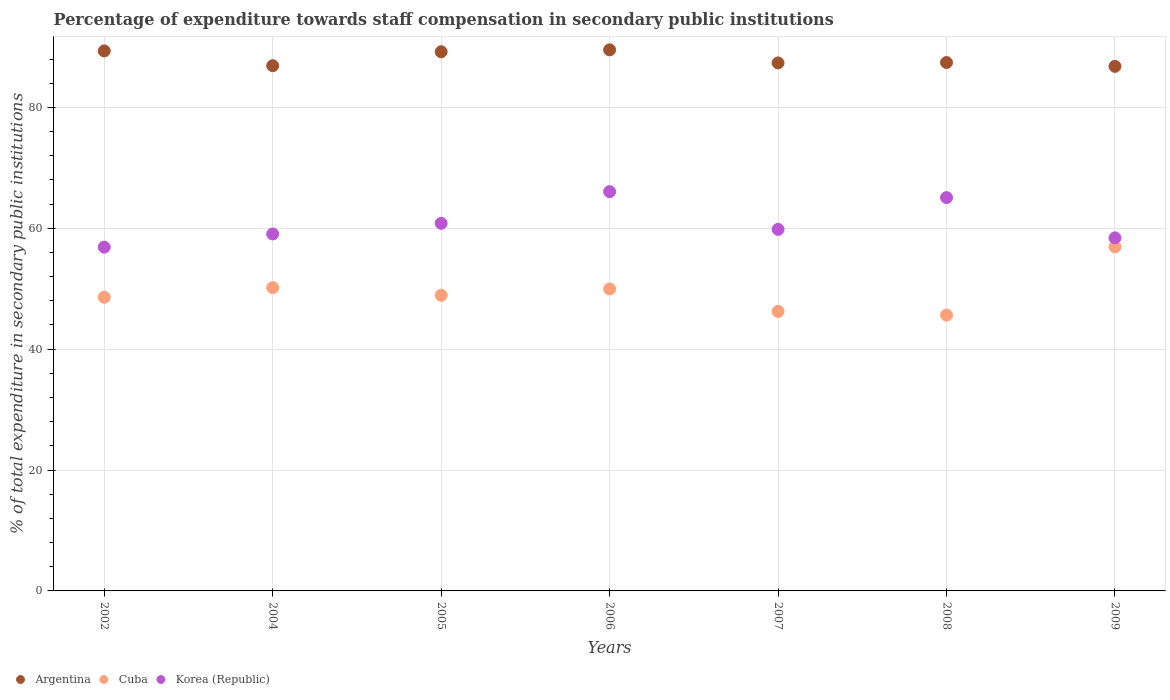How many different coloured dotlines are there?
Give a very brief answer. 3. Is the number of dotlines equal to the number of legend labels?
Offer a terse response. Yes. What is the percentage of expenditure towards staff compensation in Korea (Republic) in 2002?
Keep it short and to the point. 56.87. Across all years, what is the maximum percentage of expenditure towards staff compensation in Cuba?
Your answer should be very brief. 56.92. Across all years, what is the minimum percentage of expenditure towards staff compensation in Korea (Republic)?
Offer a terse response. 56.87. In which year was the percentage of expenditure towards staff compensation in Argentina minimum?
Offer a very short reply. 2009. What is the total percentage of expenditure towards staff compensation in Argentina in the graph?
Your answer should be compact. 616.55. What is the difference between the percentage of expenditure towards staff compensation in Cuba in 2004 and that in 2008?
Make the answer very short. 4.55. What is the difference between the percentage of expenditure towards staff compensation in Korea (Republic) in 2005 and the percentage of expenditure towards staff compensation in Argentina in 2008?
Your answer should be very brief. -26.61. What is the average percentage of expenditure towards staff compensation in Cuba per year?
Provide a short and direct response. 49.49. In the year 2005, what is the difference between the percentage of expenditure towards staff compensation in Korea (Republic) and percentage of expenditure towards staff compensation in Cuba?
Your answer should be compact. 11.9. What is the ratio of the percentage of expenditure towards staff compensation in Argentina in 2005 to that in 2006?
Provide a succinct answer. 1. Is the difference between the percentage of expenditure towards staff compensation in Korea (Republic) in 2007 and 2009 greater than the difference between the percentage of expenditure towards staff compensation in Cuba in 2007 and 2009?
Provide a short and direct response. Yes. What is the difference between the highest and the second highest percentage of expenditure towards staff compensation in Argentina?
Your answer should be compact. 0.18. What is the difference between the highest and the lowest percentage of expenditure towards staff compensation in Korea (Republic)?
Make the answer very short. 9.19. In how many years, is the percentage of expenditure towards staff compensation in Argentina greater than the average percentage of expenditure towards staff compensation in Argentina taken over all years?
Offer a terse response. 3. Does the percentage of expenditure towards staff compensation in Argentina monotonically increase over the years?
Your answer should be very brief. No. Is the percentage of expenditure towards staff compensation in Cuba strictly greater than the percentage of expenditure towards staff compensation in Argentina over the years?
Your answer should be very brief. No. How many dotlines are there?
Provide a short and direct response. 3. What is the difference between two consecutive major ticks on the Y-axis?
Keep it short and to the point. 20. Are the values on the major ticks of Y-axis written in scientific E-notation?
Your answer should be very brief. No. Does the graph contain any zero values?
Keep it short and to the point. No. How many legend labels are there?
Offer a terse response. 3. How are the legend labels stacked?
Offer a terse response. Horizontal. What is the title of the graph?
Make the answer very short. Percentage of expenditure towards staff compensation in secondary public institutions. What is the label or title of the X-axis?
Ensure brevity in your answer.  Years. What is the label or title of the Y-axis?
Your answer should be very brief. % of total expenditure in secondary public institutions. What is the % of total expenditure in secondary public institutions in Argentina in 2002?
Your answer should be very brief. 89.35. What is the % of total expenditure in secondary public institutions of Cuba in 2002?
Make the answer very short. 48.59. What is the % of total expenditure in secondary public institutions in Korea (Republic) in 2002?
Provide a short and direct response. 56.87. What is the % of total expenditure in secondary public institutions of Argentina in 2004?
Give a very brief answer. 86.9. What is the % of total expenditure in secondary public institutions of Cuba in 2004?
Keep it short and to the point. 50.18. What is the % of total expenditure in secondary public institutions of Korea (Republic) in 2004?
Keep it short and to the point. 59.06. What is the % of total expenditure in secondary public institutions in Argentina in 2005?
Your answer should be very brief. 89.2. What is the % of total expenditure in secondary public institutions of Cuba in 2005?
Keep it short and to the point. 48.92. What is the % of total expenditure in secondary public institutions in Korea (Republic) in 2005?
Offer a terse response. 60.82. What is the % of total expenditure in secondary public institutions of Argentina in 2006?
Ensure brevity in your answer.  89.52. What is the % of total expenditure in secondary public institutions of Cuba in 2006?
Ensure brevity in your answer.  49.97. What is the % of total expenditure in secondary public institutions of Korea (Republic) in 2006?
Make the answer very short. 66.06. What is the % of total expenditure in secondary public institutions in Argentina in 2007?
Give a very brief answer. 87.36. What is the % of total expenditure in secondary public institutions of Cuba in 2007?
Offer a terse response. 46.25. What is the % of total expenditure in secondary public institutions of Korea (Republic) in 2007?
Provide a succinct answer. 59.82. What is the % of total expenditure in secondary public institutions of Argentina in 2008?
Keep it short and to the point. 87.43. What is the % of total expenditure in secondary public institutions of Cuba in 2008?
Offer a terse response. 45.63. What is the % of total expenditure in secondary public institutions of Korea (Republic) in 2008?
Your response must be concise. 65.08. What is the % of total expenditure in secondary public institutions of Argentina in 2009?
Make the answer very short. 86.79. What is the % of total expenditure in secondary public institutions in Cuba in 2009?
Provide a succinct answer. 56.92. What is the % of total expenditure in secondary public institutions in Korea (Republic) in 2009?
Offer a terse response. 58.42. Across all years, what is the maximum % of total expenditure in secondary public institutions of Argentina?
Offer a very short reply. 89.52. Across all years, what is the maximum % of total expenditure in secondary public institutions of Cuba?
Offer a very short reply. 56.92. Across all years, what is the maximum % of total expenditure in secondary public institutions of Korea (Republic)?
Offer a very short reply. 66.06. Across all years, what is the minimum % of total expenditure in secondary public institutions in Argentina?
Your answer should be compact. 86.79. Across all years, what is the minimum % of total expenditure in secondary public institutions of Cuba?
Offer a terse response. 45.63. Across all years, what is the minimum % of total expenditure in secondary public institutions of Korea (Republic)?
Keep it short and to the point. 56.87. What is the total % of total expenditure in secondary public institutions of Argentina in the graph?
Your answer should be very brief. 616.55. What is the total % of total expenditure in secondary public institutions in Cuba in the graph?
Give a very brief answer. 346.45. What is the total % of total expenditure in secondary public institutions in Korea (Republic) in the graph?
Offer a very short reply. 426.13. What is the difference between the % of total expenditure in secondary public institutions of Argentina in 2002 and that in 2004?
Keep it short and to the point. 2.45. What is the difference between the % of total expenditure in secondary public institutions of Cuba in 2002 and that in 2004?
Your response must be concise. -1.59. What is the difference between the % of total expenditure in secondary public institutions in Korea (Republic) in 2002 and that in 2004?
Provide a succinct answer. -2.19. What is the difference between the % of total expenditure in secondary public institutions of Argentina in 2002 and that in 2005?
Give a very brief answer. 0.14. What is the difference between the % of total expenditure in secondary public institutions in Cuba in 2002 and that in 2005?
Offer a terse response. -0.33. What is the difference between the % of total expenditure in secondary public institutions in Korea (Republic) in 2002 and that in 2005?
Offer a very short reply. -3.94. What is the difference between the % of total expenditure in secondary public institutions in Argentina in 2002 and that in 2006?
Make the answer very short. -0.18. What is the difference between the % of total expenditure in secondary public institutions of Cuba in 2002 and that in 2006?
Ensure brevity in your answer.  -1.38. What is the difference between the % of total expenditure in secondary public institutions in Korea (Republic) in 2002 and that in 2006?
Your response must be concise. -9.19. What is the difference between the % of total expenditure in secondary public institutions of Argentina in 2002 and that in 2007?
Offer a very short reply. 1.99. What is the difference between the % of total expenditure in secondary public institutions in Cuba in 2002 and that in 2007?
Ensure brevity in your answer.  2.34. What is the difference between the % of total expenditure in secondary public institutions in Korea (Republic) in 2002 and that in 2007?
Offer a terse response. -2.94. What is the difference between the % of total expenditure in secondary public institutions of Argentina in 2002 and that in 2008?
Your response must be concise. 1.92. What is the difference between the % of total expenditure in secondary public institutions in Cuba in 2002 and that in 2008?
Provide a short and direct response. 2.96. What is the difference between the % of total expenditure in secondary public institutions in Korea (Republic) in 2002 and that in 2008?
Make the answer very short. -8.2. What is the difference between the % of total expenditure in secondary public institutions of Argentina in 2002 and that in 2009?
Give a very brief answer. 2.55. What is the difference between the % of total expenditure in secondary public institutions of Cuba in 2002 and that in 2009?
Keep it short and to the point. -8.34. What is the difference between the % of total expenditure in secondary public institutions of Korea (Republic) in 2002 and that in 2009?
Make the answer very short. -1.54. What is the difference between the % of total expenditure in secondary public institutions in Argentina in 2004 and that in 2005?
Provide a succinct answer. -2.3. What is the difference between the % of total expenditure in secondary public institutions in Cuba in 2004 and that in 2005?
Provide a succinct answer. 1.26. What is the difference between the % of total expenditure in secondary public institutions of Korea (Republic) in 2004 and that in 2005?
Give a very brief answer. -1.76. What is the difference between the % of total expenditure in secondary public institutions in Argentina in 2004 and that in 2006?
Provide a short and direct response. -2.62. What is the difference between the % of total expenditure in secondary public institutions of Cuba in 2004 and that in 2006?
Offer a very short reply. 0.21. What is the difference between the % of total expenditure in secondary public institutions in Korea (Republic) in 2004 and that in 2006?
Offer a very short reply. -7. What is the difference between the % of total expenditure in secondary public institutions of Argentina in 2004 and that in 2007?
Ensure brevity in your answer.  -0.46. What is the difference between the % of total expenditure in secondary public institutions in Cuba in 2004 and that in 2007?
Your answer should be compact. 3.93. What is the difference between the % of total expenditure in secondary public institutions in Korea (Republic) in 2004 and that in 2007?
Provide a succinct answer. -0.76. What is the difference between the % of total expenditure in secondary public institutions of Argentina in 2004 and that in 2008?
Your answer should be very brief. -0.53. What is the difference between the % of total expenditure in secondary public institutions of Cuba in 2004 and that in 2008?
Provide a short and direct response. 4.55. What is the difference between the % of total expenditure in secondary public institutions of Korea (Republic) in 2004 and that in 2008?
Keep it short and to the point. -6.02. What is the difference between the % of total expenditure in secondary public institutions in Argentina in 2004 and that in 2009?
Provide a short and direct response. 0.11. What is the difference between the % of total expenditure in secondary public institutions of Cuba in 2004 and that in 2009?
Make the answer very short. -6.74. What is the difference between the % of total expenditure in secondary public institutions of Korea (Republic) in 2004 and that in 2009?
Provide a succinct answer. 0.64. What is the difference between the % of total expenditure in secondary public institutions in Argentina in 2005 and that in 2006?
Provide a succinct answer. -0.32. What is the difference between the % of total expenditure in secondary public institutions of Cuba in 2005 and that in 2006?
Your response must be concise. -1.05. What is the difference between the % of total expenditure in secondary public institutions of Korea (Republic) in 2005 and that in 2006?
Offer a terse response. -5.24. What is the difference between the % of total expenditure in secondary public institutions in Argentina in 2005 and that in 2007?
Provide a succinct answer. 1.85. What is the difference between the % of total expenditure in secondary public institutions of Cuba in 2005 and that in 2007?
Ensure brevity in your answer.  2.67. What is the difference between the % of total expenditure in secondary public institutions of Argentina in 2005 and that in 2008?
Your response must be concise. 1.78. What is the difference between the % of total expenditure in secondary public institutions in Cuba in 2005 and that in 2008?
Your answer should be compact. 3.29. What is the difference between the % of total expenditure in secondary public institutions in Korea (Republic) in 2005 and that in 2008?
Your answer should be compact. -4.26. What is the difference between the % of total expenditure in secondary public institutions of Argentina in 2005 and that in 2009?
Provide a short and direct response. 2.41. What is the difference between the % of total expenditure in secondary public institutions of Cuba in 2005 and that in 2009?
Give a very brief answer. -8.01. What is the difference between the % of total expenditure in secondary public institutions in Korea (Republic) in 2005 and that in 2009?
Provide a short and direct response. 2.4. What is the difference between the % of total expenditure in secondary public institutions of Argentina in 2006 and that in 2007?
Your response must be concise. 2.16. What is the difference between the % of total expenditure in secondary public institutions of Cuba in 2006 and that in 2007?
Your answer should be very brief. 3.72. What is the difference between the % of total expenditure in secondary public institutions in Korea (Republic) in 2006 and that in 2007?
Provide a succinct answer. 6.24. What is the difference between the % of total expenditure in secondary public institutions of Argentina in 2006 and that in 2008?
Make the answer very short. 2.1. What is the difference between the % of total expenditure in secondary public institutions in Cuba in 2006 and that in 2008?
Your response must be concise. 4.33. What is the difference between the % of total expenditure in secondary public institutions of Korea (Republic) in 2006 and that in 2008?
Give a very brief answer. 0.98. What is the difference between the % of total expenditure in secondary public institutions in Argentina in 2006 and that in 2009?
Offer a terse response. 2.73. What is the difference between the % of total expenditure in secondary public institutions in Cuba in 2006 and that in 2009?
Make the answer very short. -6.96. What is the difference between the % of total expenditure in secondary public institutions in Korea (Republic) in 2006 and that in 2009?
Your answer should be very brief. 7.64. What is the difference between the % of total expenditure in secondary public institutions in Argentina in 2007 and that in 2008?
Provide a short and direct response. -0.07. What is the difference between the % of total expenditure in secondary public institutions in Cuba in 2007 and that in 2008?
Give a very brief answer. 0.62. What is the difference between the % of total expenditure in secondary public institutions in Korea (Republic) in 2007 and that in 2008?
Make the answer very short. -5.26. What is the difference between the % of total expenditure in secondary public institutions of Argentina in 2007 and that in 2009?
Your answer should be very brief. 0.57. What is the difference between the % of total expenditure in secondary public institutions of Cuba in 2007 and that in 2009?
Give a very brief answer. -10.68. What is the difference between the % of total expenditure in secondary public institutions of Korea (Republic) in 2007 and that in 2009?
Keep it short and to the point. 1.4. What is the difference between the % of total expenditure in secondary public institutions of Argentina in 2008 and that in 2009?
Keep it short and to the point. 0.64. What is the difference between the % of total expenditure in secondary public institutions in Cuba in 2008 and that in 2009?
Ensure brevity in your answer.  -11.29. What is the difference between the % of total expenditure in secondary public institutions in Korea (Republic) in 2008 and that in 2009?
Make the answer very short. 6.66. What is the difference between the % of total expenditure in secondary public institutions in Argentina in 2002 and the % of total expenditure in secondary public institutions in Cuba in 2004?
Provide a succinct answer. 39.17. What is the difference between the % of total expenditure in secondary public institutions in Argentina in 2002 and the % of total expenditure in secondary public institutions in Korea (Republic) in 2004?
Your answer should be very brief. 30.28. What is the difference between the % of total expenditure in secondary public institutions in Cuba in 2002 and the % of total expenditure in secondary public institutions in Korea (Republic) in 2004?
Keep it short and to the point. -10.47. What is the difference between the % of total expenditure in secondary public institutions in Argentina in 2002 and the % of total expenditure in secondary public institutions in Cuba in 2005?
Your answer should be compact. 40.43. What is the difference between the % of total expenditure in secondary public institutions of Argentina in 2002 and the % of total expenditure in secondary public institutions of Korea (Republic) in 2005?
Keep it short and to the point. 28.53. What is the difference between the % of total expenditure in secondary public institutions in Cuba in 2002 and the % of total expenditure in secondary public institutions in Korea (Republic) in 2005?
Give a very brief answer. -12.23. What is the difference between the % of total expenditure in secondary public institutions of Argentina in 2002 and the % of total expenditure in secondary public institutions of Cuba in 2006?
Offer a terse response. 39.38. What is the difference between the % of total expenditure in secondary public institutions of Argentina in 2002 and the % of total expenditure in secondary public institutions of Korea (Republic) in 2006?
Give a very brief answer. 23.28. What is the difference between the % of total expenditure in secondary public institutions of Cuba in 2002 and the % of total expenditure in secondary public institutions of Korea (Republic) in 2006?
Your answer should be compact. -17.47. What is the difference between the % of total expenditure in secondary public institutions of Argentina in 2002 and the % of total expenditure in secondary public institutions of Cuba in 2007?
Make the answer very short. 43.1. What is the difference between the % of total expenditure in secondary public institutions in Argentina in 2002 and the % of total expenditure in secondary public institutions in Korea (Republic) in 2007?
Your answer should be compact. 29.53. What is the difference between the % of total expenditure in secondary public institutions of Cuba in 2002 and the % of total expenditure in secondary public institutions of Korea (Republic) in 2007?
Provide a succinct answer. -11.23. What is the difference between the % of total expenditure in secondary public institutions in Argentina in 2002 and the % of total expenditure in secondary public institutions in Cuba in 2008?
Provide a short and direct response. 43.71. What is the difference between the % of total expenditure in secondary public institutions in Argentina in 2002 and the % of total expenditure in secondary public institutions in Korea (Republic) in 2008?
Give a very brief answer. 24.27. What is the difference between the % of total expenditure in secondary public institutions in Cuba in 2002 and the % of total expenditure in secondary public institutions in Korea (Republic) in 2008?
Your answer should be very brief. -16.49. What is the difference between the % of total expenditure in secondary public institutions of Argentina in 2002 and the % of total expenditure in secondary public institutions of Cuba in 2009?
Provide a succinct answer. 32.42. What is the difference between the % of total expenditure in secondary public institutions in Argentina in 2002 and the % of total expenditure in secondary public institutions in Korea (Republic) in 2009?
Offer a very short reply. 30.93. What is the difference between the % of total expenditure in secondary public institutions of Cuba in 2002 and the % of total expenditure in secondary public institutions of Korea (Republic) in 2009?
Keep it short and to the point. -9.83. What is the difference between the % of total expenditure in secondary public institutions in Argentina in 2004 and the % of total expenditure in secondary public institutions in Cuba in 2005?
Make the answer very short. 37.98. What is the difference between the % of total expenditure in secondary public institutions of Argentina in 2004 and the % of total expenditure in secondary public institutions of Korea (Republic) in 2005?
Your answer should be very brief. 26.08. What is the difference between the % of total expenditure in secondary public institutions of Cuba in 2004 and the % of total expenditure in secondary public institutions of Korea (Republic) in 2005?
Your answer should be compact. -10.64. What is the difference between the % of total expenditure in secondary public institutions of Argentina in 2004 and the % of total expenditure in secondary public institutions of Cuba in 2006?
Provide a short and direct response. 36.93. What is the difference between the % of total expenditure in secondary public institutions in Argentina in 2004 and the % of total expenditure in secondary public institutions in Korea (Republic) in 2006?
Keep it short and to the point. 20.84. What is the difference between the % of total expenditure in secondary public institutions of Cuba in 2004 and the % of total expenditure in secondary public institutions of Korea (Republic) in 2006?
Ensure brevity in your answer.  -15.88. What is the difference between the % of total expenditure in secondary public institutions in Argentina in 2004 and the % of total expenditure in secondary public institutions in Cuba in 2007?
Provide a succinct answer. 40.65. What is the difference between the % of total expenditure in secondary public institutions of Argentina in 2004 and the % of total expenditure in secondary public institutions of Korea (Republic) in 2007?
Your answer should be very brief. 27.08. What is the difference between the % of total expenditure in secondary public institutions of Cuba in 2004 and the % of total expenditure in secondary public institutions of Korea (Republic) in 2007?
Ensure brevity in your answer.  -9.64. What is the difference between the % of total expenditure in secondary public institutions in Argentina in 2004 and the % of total expenditure in secondary public institutions in Cuba in 2008?
Your answer should be very brief. 41.27. What is the difference between the % of total expenditure in secondary public institutions in Argentina in 2004 and the % of total expenditure in secondary public institutions in Korea (Republic) in 2008?
Your answer should be very brief. 21.82. What is the difference between the % of total expenditure in secondary public institutions in Cuba in 2004 and the % of total expenditure in secondary public institutions in Korea (Republic) in 2008?
Provide a short and direct response. -14.9. What is the difference between the % of total expenditure in secondary public institutions of Argentina in 2004 and the % of total expenditure in secondary public institutions of Cuba in 2009?
Provide a short and direct response. 29.98. What is the difference between the % of total expenditure in secondary public institutions of Argentina in 2004 and the % of total expenditure in secondary public institutions of Korea (Republic) in 2009?
Provide a short and direct response. 28.48. What is the difference between the % of total expenditure in secondary public institutions of Cuba in 2004 and the % of total expenditure in secondary public institutions of Korea (Republic) in 2009?
Offer a very short reply. -8.24. What is the difference between the % of total expenditure in secondary public institutions in Argentina in 2005 and the % of total expenditure in secondary public institutions in Cuba in 2006?
Provide a succinct answer. 39.24. What is the difference between the % of total expenditure in secondary public institutions of Argentina in 2005 and the % of total expenditure in secondary public institutions of Korea (Republic) in 2006?
Ensure brevity in your answer.  23.14. What is the difference between the % of total expenditure in secondary public institutions in Cuba in 2005 and the % of total expenditure in secondary public institutions in Korea (Republic) in 2006?
Provide a succinct answer. -17.14. What is the difference between the % of total expenditure in secondary public institutions in Argentina in 2005 and the % of total expenditure in secondary public institutions in Cuba in 2007?
Make the answer very short. 42.96. What is the difference between the % of total expenditure in secondary public institutions in Argentina in 2005 and the % of total expenditure in secondary public institutions in Korea (Republic) in 2007?
Offer a terse response. 29.38. What is the difference between the % of total expenditure in secondary public institutions of Cuba in 2005 and the % of total expenditure in secondary public institutions of Korea (Republic) in 2007?
Ensure brevity in your answer.  -10.9. What is the difference between the % of total expenditure in secondary public institutions in Argentina in 2005 and the % of total expenditure in secondary public institutions in Cuba in 2008?
Keep it short and to the point. 43.57. What is the difference between the % of total expenditure in secondary public institutions of Argentina in 2005 and the % of total expenditure in secondary public institutions of Korea (Republic) in 2008?
Ensure brevity in your answer.  24.13. What is the difference between the % of total expenditure in secondary public institutions of Cuba in 2005 and the % of total expenditure in secondary public institutions of Korea (Republic) in 2008?
Make the answer very short. -16.16. What is the difference between the % of total expenditure in secondary public institutions of Argentina in 2005 and the % of total expenditure in secondary public institutions of Cuba in 2009?
Provide a short and direct response. 32.28. What is the difference between the % of total expenditure in secondary public institutions of Argentina in 2005 and the % of total expenditure in secondary public institutions of Korea (Republic) in 2009?
Ensure brevity in your answer.  30.79. What is the difference between the % of total expenditure in secondary public institutions of Argentina in 2006 and the % of total expenditure in secondary public institutions of Cuba in 2007?
Your answer should be compact. 43.27. What is the difference between the % of total expenditure in secondary public institutions of Argentina in 2006 and the % of total expenditure in secondary public institutions of Korea (Republic) in 2007?
Your answer should be compact. 29.7. What is the difference between the % of total expenditure in secondary public institutions in Cuba in 2006 and the % of total expenditure in secondary public institutions in Korea (Republic) in 2007?
Ensure brevity in your answer.  -9.85. What is the difference between the % of total expenditure in secondary public institutions of Argentina in 2006 and the % of total expenditure in secondary public institutions of Cuba in 2008?
Your answer should be very brief. 43.89. What is the difference between the % of total expenditure in secondary public institutions of Argentina in 2006 and the % of total expenditure in secondary public institutions of Korea (Republic) in 2008?
Your answer should be very brief. 24.45. What is the difference between the % of total expenditure in secondary public institutions in Cuba in 2006 and the % of total expenditure in secondary public institutions in Korea (Republic) in 2008?
Your response must be concise. -15.11. What is the difference between the % of total expenditure in secondary public institutions of Argentina in 2006 and the % of total expenditure in secondary public institutions of Cuba in 2009?
Your response must be concise. 32.6. What is the difference between the % of total expenditure in secondary public institutions of Argentina in 2006 and the % of total expenditure in secondary public institutions of Korea (Republic) in 2009?
Provide a succinct answer. 31.11. What is the difference between the % of total expenditure in secondary public institutions of Cuba in 2006 and the % of total expenditure in secondary public institutions of Korea (Republic) in 2009?
Your answer should be compact. -8.45. What is the difference between the % of total expenditure in secondary public institutions of Argentina in 2007 and the % of total expenditure in secondary public institutions of Cuba in 2008?
Your answer should be compact. 41.73. What is the difference between the % of total expenditure in secondary public institutions of Argentina in 2007 and the % of total expenditure in secondary public institutions of Korea (Republic) in 2008?
Make the answer very short. 22.28. What is the difference between the % of total expenditure in secondary public institutions of Cuba in 2007 and the % of total expenditure in secondary public institutions of Korea (Republic) in 2008?
Offer a terse response. -18.83. What is the difference between the % of total expenditure in secondary public institutions of Argentina in 2007 and the % of total expenditure in secondary public institutions of Cuba in 2009?
Offer a very short reply. 30.43. What is the difference between the % of total expenditure in secondary public institutions in Argentina in 2007 and the % of total expenditure in secondary public institutions in Korea (Republic) in 2009?
Keep it short and to the point. 28.94. What is the difference between the % of total expenditure in secondary public institutions of Cuba in 2007 and the % of total expenditure in secondary public institutions of Korea (Republic) in 2009?
Give a very brief answer. -12.17. What is the difference between the % of total expenditure in secondary public institutions in Argentina in 2008 and the % of total expenditure in secondary public institutions in Cuba in 2009?
Offer a very short reply. 30.5. What is the difference between the % of total expenditure in secondary public institutions of Argentina in 2008 and the % of total expenditure in secondary public institutions of Korea (Republic) in 2009?
Ensure brevity in your answer.  29.01. What is the difference between the % of total expenditure in secondary public institutions of Cuba in 2008 and the % of total expenditure in secondary public institutions of Korea (Republic) in 2009?
Offer a very short reply. -12.79. What is the average % of total expenditure in secondary public institutions in Argentina per year?
Keep it short and to the point. 88.08. What is the average % of total expenditure in secondary public institutions of Cuba per year?
Offer a terse response. 49.49. What is the average % of total expenditure in secondary public institutions in Korea (Republic) per year?
Your answer should be very brief. 60.88. In the year 2002, what is the difference between the % of total expenditure in secondary public institutions of Argentina and % of total expenditure in secondary public institutions of Cuba?
Ensure brevity in your answer.  40.76. In the year 2002, what is the difference between the % of total expenditure in secondary public institutions in Argentina and % of total expenditure in secondary public institutions in Korea (Republic)?
Your answer should be very brief. 32.47. In the year 2002, what is the difference between the % of total expenditure in secondary public institutions in Cuba and % of total expenditure in secondary public institutions in Korea (Republic)?
Ensure brevity in your answer.  -8.29. In the year 2004, what is the difference between the % of total expenditure in secondary public institutions of Argentina and % of total expenditure in secondary public institutions of Cuba?
Your response must be concise. 36.72. In the year 2004, what is the difference between the % of total expenditure in secondary public institutions of Argentina and % of total expenditure in secondary public institutions of Korea (Republic)?
Your answer should be very brief. 27.84. In the year 2004, what is the difference between the % of total expenditure in secondary public institutions of Cuba and % of total expenditure in secondary public institutions of Korea (Republic)?
Keep it short and to the point. -8.88. In the year 2005, what is the difference between the % of total expenditure in secondary public institutions of Argentina and % of total expenditure in secondary public institutions of Cuba?
Offer a very short reply. 40.29. In the year 2005, what is the difference between the % of total expenditure in secondary public institutions in Argentina and % of total expenditure in secondary public institutions in Korea (Republic)?
Give a very brief answer. 28.38. In the year 2005, what is the difference between the % of total expenditure in secondary public institutions in Cuba and % of total expenditure in secondary public institutions in Korea (Republic)?
Your answer should be very brief. -11.9. In the year 2006, what is the difference between the % of total expenditure in secondary public institutions in Argentina and % of total expenditure in secondary public institutions in Cuba?
Provide a succinct answer. 39.56. In the year 2006, what is the difference between the % of total expenditure in secondary public institutions in Argentina and % of total expenditure in secondary public institutions in Korea (Republic)?
Offer a very short reply. 23.46. In the year 2006, what is the difference between the % of total expenditure in secondary public institutions of Cuba and % of total expenditure in secondary public institutions of Korea (Republic)?
Provide a succinct answer. -16.1. In the year 2007, what is the difference between the % of total expenditure in secondary public institutions of Argentina and % of total expenditure in secondary public institutions of Cuba?
Keep it short and to the point. 41.11. In the year 2007, what is the difference between the % of total expenditure in secondary public institutions in Argentina and % of total expenditure in secondary public institutions in Korea (Republic)?
Your answer should be compact. 27.54. In the year 2007, what is the difference between the % of total expenditure in secondary public institutions in Cuba and % of total expenditure in secondary public institutions in Korea (Republic)?
Your response must be concise. -13.57. In the year 2008, what is the difference between the % of total expenditure in secondary public institutions of Argentina and % of total expenditure in secondary public institutions of Cuba?
Give a very brief answer. 41.8. In the year 2008, what is the difference between the % of total expenditure in secondary public institutions in Argentina and % of total expenditure in secondary public institutions in Korea (Republic)?
Your response must be concise. 22.35. In the year 2008, what is the difference between the % of total expenditure in secondary public institutions of Cuba and % of total expenditure in secondary public institutions of Korea (Republic)?
Provide a short and direct response. -19.45. In the year 2009, what is the difference between the % of total expenditure in secondary public institutions of Argentina and % of total expenditure in secondary public institutions of Cuba?
Make the answer very short. 29.87. In the year 2009, what is the difference between the % of total expenditure in secondary public institutions in Argentina and % of total expenditure in secondary public institutions in Korea (Republic)?
Offer a very short reply. 28.37. In the year 2009, what is the difference between the % of total expenditure in secondary public institutions in Cuba and % of total expenditure in secondary public institutions in Korea (Republic)?
Make the answer very short. -1.49. What is the ratio of the % of total expenditure in secondary public institutions in Argentina in 2002 to that in 2004?
Offer a very short reply. 1.03. What is the ratio of the % of total expenditure in secondary public institutions in Cuba in 2002 to that in 2004?
Give a very brief answer. 0.97. What is the ratio of the % of total expenditure in secondary public institutions in Korea (Republic) in 2002 to that in 2004?
Give a very brief answer. 0.96. What is the ratio of the % of total expenditure in secondary public institutions of Cuba in 2002 to that in 2005?
Provide a short and direct response. 0.99. What is the ratio of the % of total expenditure in secondary public institutions of Korea (Republic) in 2002 to that in 2005?
Your answer should be very brief. 0.94. What is the ratio of the % of total expenditure in secondary public institutions in Argentina in 2002 to that in 2006?
Make the answer very short. 1. What is the ratio of the % of total expenditure in secondary public institutions of Cuba in 2002 to that in 2006?
Make the answer very short. 0.97. What is the ratio of the % of total expenditure in secondary public institutions of Korea (Republic) in 2002 to that in 2006?
Provide a succinct answer. 0.86. What is the ratio of the % of total expenditure in secondary public institutions of Argentina in 2002 to that in 2007?
Your answer should be compact. 1.02. What is the ratio of the % of total expenditure in secondary public institutions in Cuba in 2002 to that in 2007?
Give a very brief answer. 1.05. What is the ratio of the % of total expenditure in secondary public institutions of Korea (Republic) in 2002 to that in 2007?
Your answer should be very brief. 0.95. What is the ratio of the % of total expenditure in secondary public institutions of Argentina in 2002 to that in 2008?
Offer a terse response. 1.02. What is the ratio of the % of total expenditure in secondary public institutions in Cuba in 2002 to that in 2008?
Your answer should be very brief. 1.06. What is the ratio of the % of total expenditure in secondary public institutions in Korea (Republic) in 2002 to that in 2008?
Ensure brevity in your answer.  0.87. What is the ratio of the % of total expenditure in secondary public institutions in Argentina in 2002 to that in 2009?
Your answer should be very brief. 1.03. What is the ratio of the % of total expenditure in secondary public institutions in Cuba in 2002 to that in 2009?
Ensure brevity in your answer.  0.85. What is the ratio of the % of total expenditure in secondary public institutions of Korea (Republic) in 2002 to that in 2009?
Provide a short and direct response. 0.97. What is the ratio of the % of total expenditure in secondary public institutions in Argentina in 2004 to that in 2005?
Your answer should be very brief. 0.97. What is the ratio of the % of total expenditure in secondary public institutions in Cuba in 2004 to that in 2005?
Keep it short and to the point. 1.03. What is the ratio of the % of total expenditure in secondary public institutions of Korea (Republic) in 2004 to that in 2005?
Give a very brief answer. 0.97. What is the ratio of the % of total expenditure in secondary public institutions of Argentina in 2004 to that in 2006?
Give a very brief answer. 0.97. What is the ratio of the % of total expenditure in secondary public institutions of Korea (Republic) in 2004 to that in 2006?
Provide a succinct answer. 0.89. What is the ratio of the % of total expenditure in secondary public institutions in Cuba in 2004 to that in 2007?
Provide a short and direct response. 1.08. What is the ratio of the % of total expenditure in secondary public institutions in Korea (Republic) in 2004 to that in 2007?
Provide a short and direct response. 0.99. What is the ratio of the % of total expenditure in secondary public institutions in Argentina in 2004 to that in 2008?
Your answer should be very brief. 0.99. What is the ratio of the % of total expenditure in secondary public institutions in Cuba in 2004 to that in 2008?
Keep it short and to the point. 1.1. What is the ratio of the % of total expenditure in secondary public institutions in Korea (Republic) in 2004 to that in 2008?
Make the answer very short. 0.91. What is the ratio of the % of total expenditure in secondary public institutions in Argentina in 2004 to that in 2009?
Your response must be concise. 1. What is the ratio of the % of total expenditure in secondary public institutions of Cuba in 2004 to that in 2009?
Offer a terse response. 0.88. What is the ratio of the % of total expenditure in secondary public institutions of Korea (Republic) in 2004 to that in 2009?
Provide a short and direct response. 1.01. What is the ratio of the % of total expenditure in secondary public institutions of Argentina in 2005 to that in 2006?
Your answer should be compact. 1. What is the ratio of the % of total expenditure in secondary public institutions of Korea (Republic) in 2005 to that in 2006?
Make the answer very short. 0.92. What is the ratio of the % of total expenditure in secondary public institutions in Argentina in 2005 to that in 2007?
Your answer should be very brief. 1.02. What is the ratio of the % of total expenditure in secondary public institutions in Cuba in 2005 to that in 2007?
Your answer should be very brief. 1.06. What is the ratio of the % of total expenditure in secondary public institutions of Korea (Republic) in 2005 to that in 2007?
Ensure brevity in your answer.  1.02. What is the ratio of the % of total expenditure in secondary public institutions in Argentina in 2005 to that in 2008?
Offer a very short reply. 1.02. What is the ratio of the % of total expenditure in secondary public institutions in Cuba in 2005 to that in 2008?
Provide a short and direct response. 1.07. What is the ratio of the % of total expenditure in secondary public institutions in Korea (Republic) in 2005 to that in 2008?
Keep it short and to the point. 0.93. What is the ratio of the % of total expenditure in secondary public institutions of Argentina in 2005 to that in 2009?
Give a very brief answer. 1.03. What is the ratio of the % of total expenditure in secondary public institutions of Cuba in 2005 to that in 2009?
Offer a very short reply. 0.86. What is the ratio of the % of total expenditure in secondary public institutions in Korea (Republic) in 2005 to that in 2009?
Ensure brevity in your answer.  1.04. What is the ratio of the % of total expenditure in secondary public institutions in Argentina in 2006 to that in 2007?
Provide a short and direct response. 1.02. What is the ratio of the % of total expenditure in secondary public institutions of Cuba in 2006 to that in 2007?
Your answer should be compact. 1.08. What is the ratio of the % of total expenditure in secondary public institutions of Korea (Republic) in 2006 to that in 2007?
Offer a very short reply. 1.1. What is the ratio of the % of total expenditure in secondary public institutions of Argentina in 2006 to that in 2008?
Keep it short and to the point. 1.02. What is the ratio of the % of total expenditure in secondary public institutions in Cuba in 2006 to that in 2008?
Offer a terse response. 1.09. What is the ratio of the % of total expenditure in secondary public institutions in Korea (Republic) in 2006 to that in 2008?
Make the answer very short. 1.02. What is the ratio of the % of total expenditure in secondary public institutions in Argentina in 2006 to that in 2009?
Keep it short and to the point. 1.03. What is the ratio of the % of total expenditure in secondary public institutions in Cuba in 2006 to that in 2009?
Give a very brief answer. 0.88. What is the ratio of the % of total expenditure in secondary public institutions in Korea (Republic) in 2006 to that in 2009?
Provide a succinct answer. 1.13. What is the ratio of the % of total expenditure in secondary public institutions in Cuba in 2007 to that in 2008?
Your response must be concise. 1.01. What is the ratio of the % of total expenditure in secondary public institutions in Korea (Republic) in 2007 to that in 2008?
Keep it short and to the point. 0.92. What is the ratio of the % of total expenditure in secondary public institutions of Argentina in 2007 to that in 2009?
Give a very brief answer. 1.01. What is the ratio of the % of total expenditure in secondary public institutions in Cuba in 2007 to that in 2009?
Ensure brevity in your answer.  0.81. What is the ratio of the % of total expenditure in secondary public institutions of Korea (Republic) in 2007 to that in 2009?
Ensure brevity in your answer.  1.02. What is the ratio of the % of total expenditure in secondary public institutions in Argentina in 2008 to that in 2009?
Your answer should be compact. 1.01. What is the ratio of the % of total expenditure in secondary public institutions in Cuba in 2008 to that in 2009?
Keep it short and to the point. 0.8. What is the ratio of the % of total expenditure in secondary public institutions of Korea (Republic) in 2008 to that in 2009?
Give a very brief answer. 1.11. What is the difference between the highest and the second highest % of total expenditure in secondary public institutions in Argentina?
Your answer should be very brief. 0.18. What is the difference between the highest and the second highest % of total expenditure in secondary public institutions of Cuba?
Provide a succinct answer. 6.74. What is the difference between the highest and the second highest % of total expenditure in secondary public institutions of Korea (Republic)?
Your answer should be compact. 0.98. What is the difference between the highest and the lowest % of total expenditure in secondary public institutions in Argentina?
Your response must be concise. 2.73. What is the difference between the highest and the lowest % of total expenditure in secondary public institutions of Cuba?
Your answer should be very brief. 11.29. What is the difference between the highest and the lowest % of total expenditure in secondary public institutions in Korea (Republic)?
Your answer should be very brief. 9.19. 